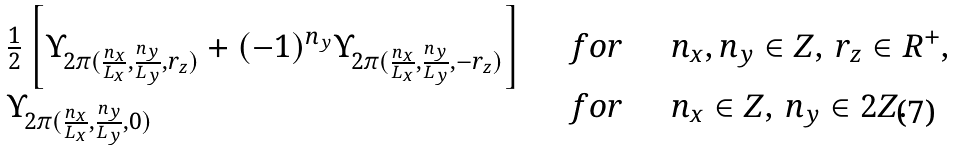<formula> <loc_0><loc_0><loc_500><loc_500>\begin{array} { l c l } \frac { 1 } { 2 } \left [ \Upsilon _ { 2 \pi ( \frac { n _ { x } } { L _ { x } } , \frac { n _ { y } } { L _ { y } } , r _ { z } ) } + ( - 1 ) ^ { n _ { y } } \Upsilon _ { 2 \pi ( \frac { n _ { x } } { L _ { x } } , \frac { n _ { y } } { L _ { y } } , - r _ { z } ) } \right ] & \quad f o r \quad & n _ { x } , n _ { y } \in Z , \, r _ { z } \in R ^ { + } , \\ \Upsilon _ { 2 \pi ( \frac { n _ { x } } { L _ { x } } , \frac { n _ { y } } { L _ { y } } , 0 ) } & \quad f o r \quad & n _ { x } \in Z , \, n _ { y } \in 2 Z . \\ \end{array}</formula> 